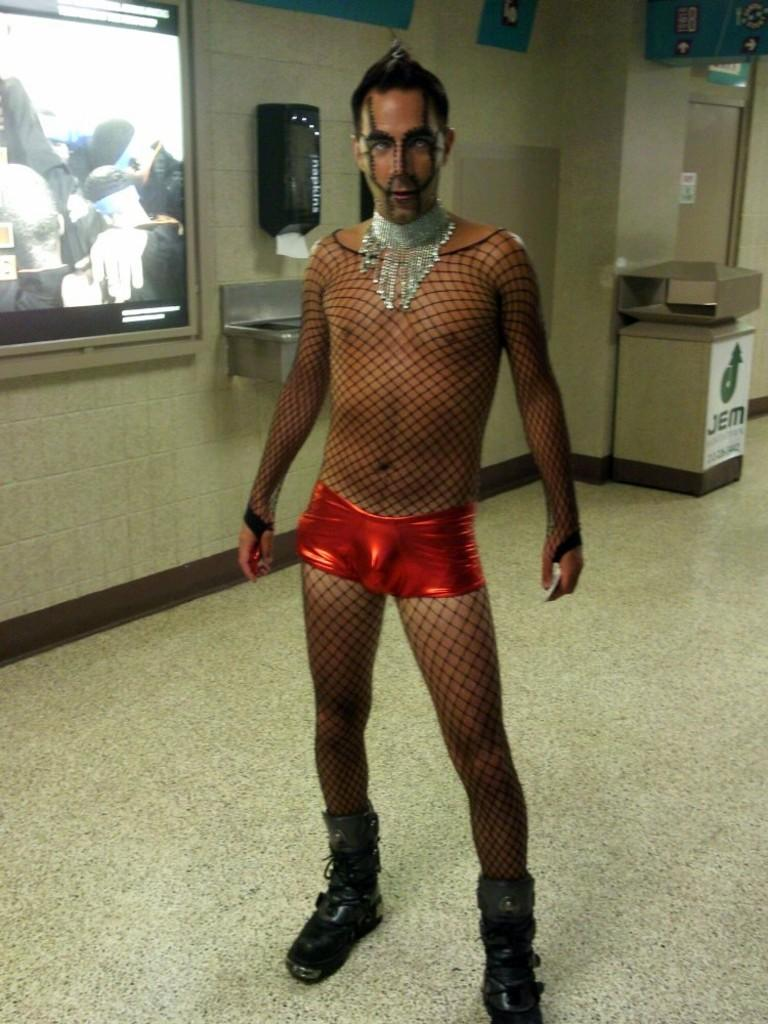What is the main subject of the image? There is a man in the image. What is the man wearing in the image? The man is wearing a black netted costume and jewelry. What is the man's position in the image? The man is standing on the floor. How does the man stop the music in the image? There is no music or indication of music in the image, so it is not possible to determine how the man might stop it. 